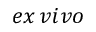<formula> <loc_0><loc_0><loc_500><loc_500>e x \, v i v o</formula> 